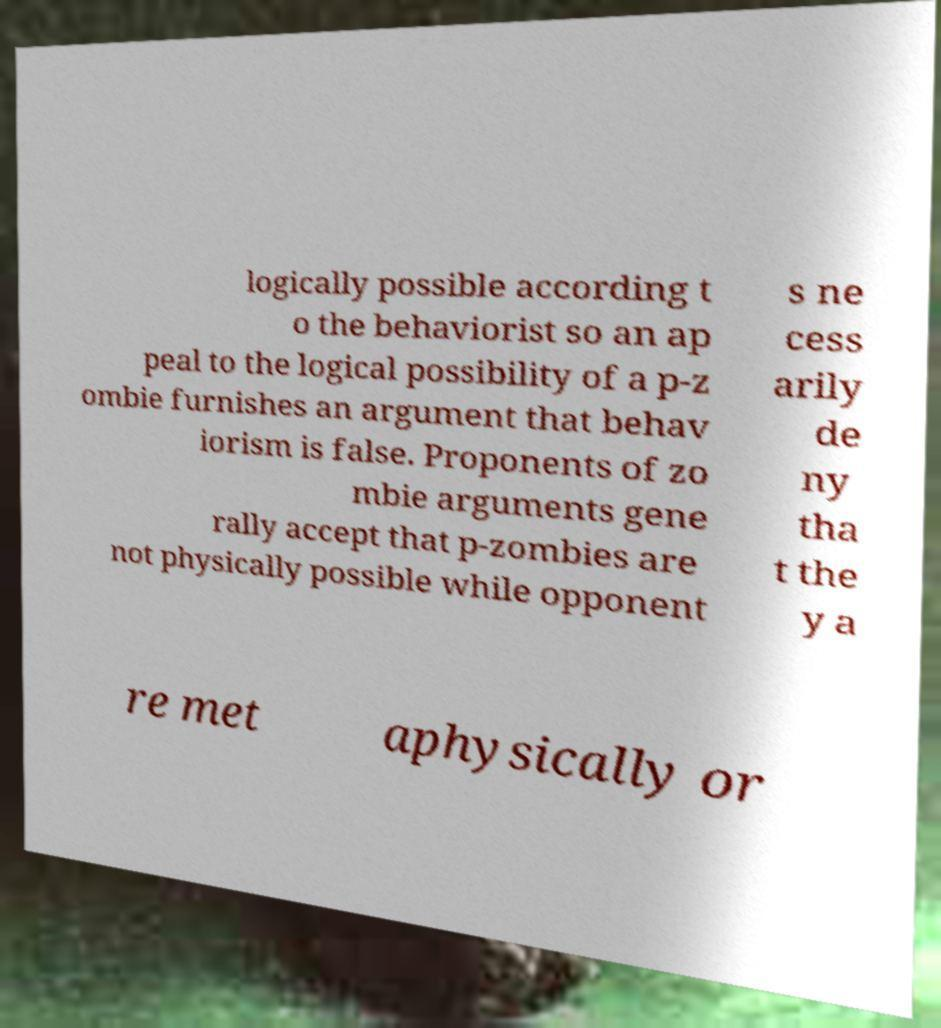There's text embedded in this image that I need extracted. Can you transcribe it verbatim? logically possible according t o the behaviorist so an ap peal to the logical possibility of a p-z ombie furnishes an argument that behav iorism is false. Proponents of zo mbie arguments gene rally accept that p-zombies are not physically possible while opponent s ne cess arily de ny tha t the y a re met aphysically or 